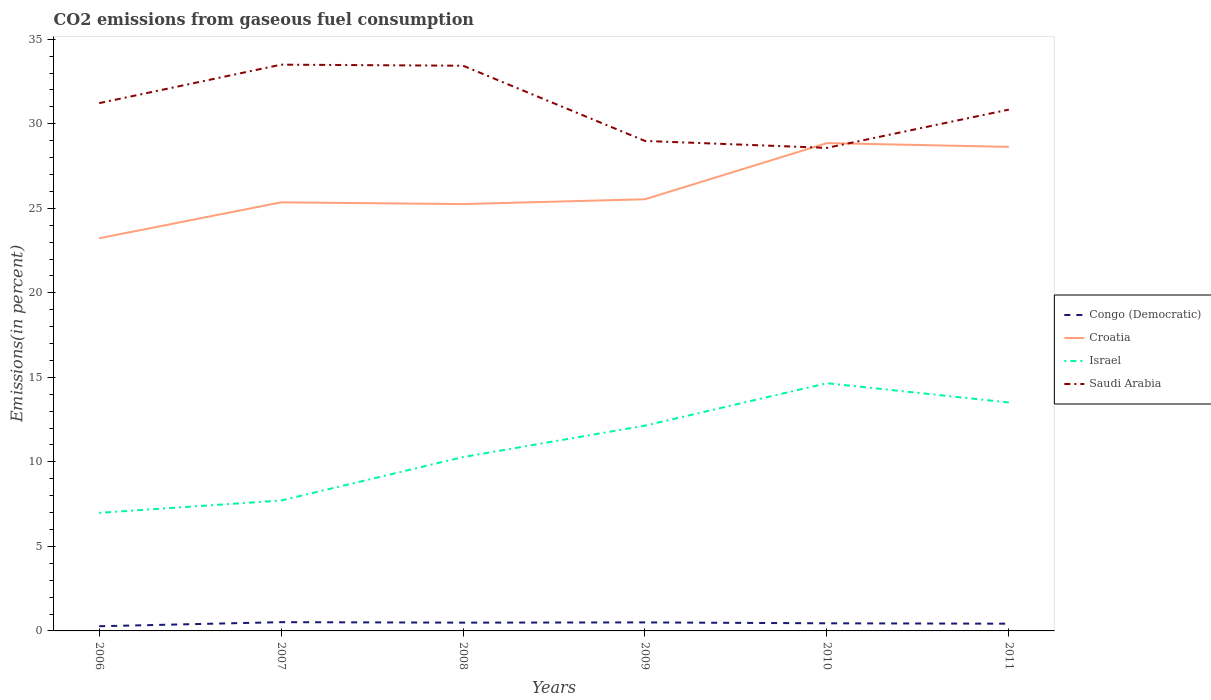How many different coloured lines are there?
Make the answer very short. 4. Is the number of lines equal to the number of legend labels?
Provide a succinct answer. Yes. Across all years, what is the maximum total CO2 emitted in Congo (Democratic)?
Provide a short and direct response. 0.28. What is the total total CO2 emitted in Israel in the graph?
Offer a very short reply. -7.67. What is the difference between the highest and the second highest total CO2 emitted in Israel?
Offer a terse response. 7.67. What is the difference between the highest and the lowest total CO2 emitted in Croatia?
Make the answer very short. 2. How many years are there in the graph?
Keep it short and to the point. 6. Are the values on the major ticks of Y-axis written in scientific E-notation?
Offer a terse response. No. How many legend labels are there?
Make the answer very short. 4. How are the legend labels stacked?
Give a very brief answer. Vertical. What is the title of the graph?
Your answer should be compact. CO2 emissions from gaseous fuel consumption. Does "Micronesia" appear as one of the legend labels in the graph?
Make the answer very short. No. What is the label or title of the X-axis?
Provide a short and direct response. Years. What is the label or title of the Y-axis?
Keep it short and to the point. Emissions(in percent). What is the Emissions(in percent) of Congo (Democratic) in 2006?
Provide a short and direct response. 0.28. What is the Emissions(in percent) in Croatia in 2006?
Your response must be concise. 23.23. What is the Emissions(in percent) of Israel in 2006?
Your response must be concise. 6.98. What is the Emissions(in percent) in Saudi Arabia in 2006?
Provide a short and direct response. 31.22. What is the Emissions(in percent) of Congo (Democratic) in 2007?
Offer a terse response. 0.52. What is the Emissions(in percent) in Croatia in 2007?
Your answer should be compact. 25.35. What is the Emissions(in percent) of Israel in 2007?
Make the answer very short. 7.72. What is the Emissions(in percent) of Saudi Arabia in 2007?
Provide a succinct answer. 33.5. What is the Emissions(in percent) in Congo (Democratic) in 2008?
Provide a succinct answer. 0.49. What is the Emissions(in percent) in Croatia in 2008?
Make the answer very short. 25.25. What is the Emissions(in percent) in Israel in 2008?
Your response must be concise. 10.29. What is the Emissions(in percent) in Saudi Arabia in 2008?
Your answer should be very brief. 33.44. What is the Emissions(in percent) in Congo (Democratic) in 2009?
Offer a terse response. 0.5. What is the Emissions(in percent) in Croatia in 2009?
Provide a short and direct response. 25.54. What is the Emissions(in percent) in Israel in 2009?
Your response must be concise. 12.14. What is the Emissions(in percent) in Saudi Arabia in 2009?
Provide a short and direct response. 28.99. What is the Emissions(in percent) of Congo (Democratic) in 2010?
Ensure brevity in your answer.  0.45. What is the Emissions(in percent) in Croatia in 2010?
Offer a terse response. 28.86. What is the Emissions(in percent) in Israel in 2010?
Provide a succinct answer. 14.65. What is the Emissions(in percent) in Saudi Arabia in 2010?
Make the answer very short. 28.57. What is the Emissions(in percent) in Congo (Democratic) in 2011?
Ensure brevity in your answer.  0.43. What is the Emissions(in percent) in Croatia in 2011?
Make the answer very short. 28.64. What is the Emissions(in percent) in Israel in 2011?
Offer a terse response. 13.51. What is the Emissions(in percent) in Saudi Arabia in 2011?
Offer a very short reply. 30.84. Across all years, what is the maximum Emissions(in percent) of Congo (Democratic)?
Offer a terse response. 0.52. Across all years, what is the maximum Emissions(in percent) in Croatia?
Your answer should be very brief. 28.86. Across all years, what is the maximum Emissions(in percent) of Israel?
Your response must be concise. 14.65. Across all years, what is the maximum Emissions(in percent) in Saudi Arabia?
Your answer should be very brief. 33.5. Across all years, what is the minimum Emissions(in percent) of Congo (Democratic)?
Ensure brevity in your answer.  0.28. Across all years, what is the minimum Emissions(in percent) of Croatia?
Your answer should be compact. 23.23. Across all years, what is the minimum Emissions(in percent) of Israel?
Your answer should be very brief. 6.98. Across all years, what is the minimum Emissions(in percent) of Saudi Arabia?
Your response must be concise. 28.57. What is the total Emissions(in percent) of Congo (Democratic) in the graph?
Your answer should be compact. 2.67. What is the total Emissions(in percent) of Croatia in the graph?
Ensure brevity in your answer.  156.86. What is the total Emissions(in percent) of Israel in the graph?
Provide a short and direct response. 65.3. What is the total Emissions(in percent) of Saudi Arabia in the graph?
Provide a short and direct response. 186.56. What is the difference between the Emissions(in percent) in Congo (Democratic) in 2006 and that in 2007?
Offer a very short reply. -0.24. What is the difference between the Emissions(in percent) in Croatia in 2006 and that in 2007?
Keep it short and to the point. -2.13. What is the difference between the Emissions(in percent) of Israel in 2006 and that in 2007?
Give a very brief answer. -0.73. What is the difference between the Emissions(in percent) in Saudi Arabia in 2006 and that in 2007?
Keep it short and to the point. -2.28. What is the difference between the Emissions(in percent) of Congo (Democratic) in 2006 and that in 2008?
Provide a short and direct response. -0.21. What is the difference between the Emissions(in percent) in Croatia in 2006 and that in 2008?
Your answer should be compact. -2.02. What is the difference between the Emissions(in percent) of Israel in 2006 and that in 2008?
Make the answer very short. -3.3. What is the difference between the Emissions(in percent) in Saudi Arabia in 2006 and that in 2008?
Make the answer very short. -2.21. What is the difference between the Emissions(in percent) in Congo (Democratic) in 2006 and that in 2009?
Keep it short and to the point. -0.23. What is the difference between the Emissions(in percent) of Croatia in 2006 and that in 2009?
Provide a succinct answer. -2.31. What is the difference between the Emissions(in percent) in Israel in 2006 and that in 2009?
Your answer should be very brief. -5.16. What is the difference between the Emissions(in percent) in Saudi Arabia in 2006 and that in 2009?
Ensure brevity in your answer.  2.24. What is the difference between the Emissions(in percent) in Congo (Democratic) in 2006 and that in 2010?
Offer a very short reply. -0.17. What is the difference between the Emissions(in percent) in Croatia in 2006 and that in 2010?
Your answer should be compact. -5.63. What is the difference between the Emissions(in percent) in Israel in 2006 and that in 2010?
Your response must be concise. -7.67. What is the difference between the Emissions(in percent) of Saudi Arabia in 2006 and that in 2010?
Make the answer very short. 2.65. What is the difference between the Emissions(in percent) of Congo (Democratic) in 2006 and that in 2011?
Your answer should be very brief. -0.15. What is the difference between the Emissions(in percent) in Croatia in 2006 and that in 2011?
Make the answer very short. -5.41. What is the difference between the Emissions(in percent) of Israel in 2006 and that in 2011?
Keep it short and to the point. -6.53. What is the difference between the Emissions(in percent) in Saudi Arabia in 2006 and that in 2011?
Make the answer very short. 0.38. What is the difference between the Emissions(in percent) of Congo (Democratic) in 2007 and that in 2008?
Provide a short and direct response. 0.03. What is the difference between the Emissions(in percent) in Croatia in 2007 and that in 2008?
Your answer should be very brief. 0.1. What is the difference between the Emissions(in percent) of Israel in 2007 and that in 2008?
Make the answer very short. -2.57. What is the difference between the Emissions(in percent) in Saudi Arabia in 2007 and that in 2008?
Ensure brevity in your answer.  0.06. What is the difference between the Emissions(in percent) of Congo (Democratic) in 2007 and that in 2009?
Offer a very short reply. 0.01. What is the difference between the Emissions(in percent) of Croatia in 2007 and that in 2009?
Your response must be concise. -0.18. What is the difference between the Emissions(in percent) of Israel in 2007 and that in 2009?
Give a very brief answer. -4.43. What is the difference between the Emissions(in percent) of Saudi Arabia in 2007 and that in 2009?
Offer a terse response. 4.51. What is the difference between the Emissions(in percent) of Congo (Democratic) in 2007 and that in 2010?
Give a very brief answer. 0.07. What is the difference between the Emissions(in percent) in Croatia in 2007 and that in 2010?
Ensure brevity in your answer.  -3.5. What is the difference between the Emissions(in percent) in Israel in 2007 and that in 2010?
Give a very brief answer. -6.94. What is the difference between the Emissions(in percent) in Saudi Arabia in 2007 and that in 2010?
Provide a succinct answer. 4.92. What is the difference between the Emissions(in percent) of Congo (Democratic) in 2007 and that in 2011?
Your answer should be compact. 0.09. What is the difference between the Emissions(in percent) of Croatia in 2007 and that in 2011?
Provide a short and direct response. -3.28. What is the difference between the Emissions(in percent) of Israel in 2007 and that in 2011?
Provide a succinct answer. -5.8. What is the difference between the Emissions(in percent) of Saudi Arabia in 2007 and that in 2011?
Keep it short and to the point. 2.66. What is the difference between the Emissions(in percent) of Congo (Democratic) in 2008 and that in 2009?
Give a very brief answer. -0.01. What is the difference between the Emissions(in percent) in Croatia in 2008 and that in 2009?
Ensure brevity in your answer.  -0.28. What is the difference between the Emissions(in percent) in Israel in 2008 and that in 2009?
Ensure brevity in your answer.  -1.86. What is the difference between the Emissions(in percent) in Saudi Arabia in 2008 and that in 2009?
Provide a short and direct response. 4.45. What is the difference between the Emissions(in percent) in Congo (Democratic) in 2008 and that in 2010?
Offer a terse response. 0.04. What is the difference between the Emissions(in percent) of Croatia in 2008 and that in 2010?
Give a very brief answer. -3.61. What is the difference between the Emissions(in percent) in Israel in 2008 and that in 2010?
Keep it short and to the point. -4.37. What is the difference between the Emissions(in percent) of Saudi Arabia in 2008 and that in 2010?
Provide a succinct answer. 4.86. What is the difference between the Emissions(in percent) in Congo (Democratic) in 2008 and that in 2011?
Give a very brief answer. 0.06. What is the difference between the Emissions(in percent) of Croatia in 2008 and that in 2011?
Offer a very short reply. -3.38. What is the difference between the Emissions(in percent) of Israel in 2008 and that in 2011?
Offer a terse response. -3.23. What is the difference between the Emissions(in percent) of Saudi Arabia in 2008 and that in 2011?
Make the answer very short. 2.6. What is the difference between the Emissions(in percent) in Congo (Democratic) in 2009 and that in 2010?
Ensure brevity in your answer.  0.05. What is the difference between the Emissions(in percent) in Croatia in 2009 and that in 2010?
Provide a short and direct response. -3.32. What is the difference between the Emissions(in percent) of Israel in 2009 and that in 2010?
Offer a terse response. -2.51. What is the difference between the Emissions(in percent) in Saudi Arabia in 2009 and that in 2010?
Your answer should be very brief. 0.41. What is the difference between the Emissions(in percent) in Congo (Democratic) in 2009 and that in 2011?
Your answer should be very brief. 0.08. What is the difference between the Emissions(in percent) in Croatia in 2009 and that in 2011?
Make the answer very short. -3.1. What is the difference between the Emissions(in percent) of Israel in 2009 and that in 2011?
Your answer should be very brief. -1.37. What is the difference between the Emissions(in percent) of Saudi Arabia in 2009 and that in 2011?
Keep it short and to the point. -1.85. What is the difference between the Emissions(in percent) of Congo (Democratic) in 2010 and that in 2011?
Your answer should be very brief. 0.02. What is the difference between the Emissions(in percent) in Croatia in 2010 and that in 2011?
Make the answer very short. 0.22. What is the difference between the Emissions(in percent) of Israel in 2010 and that in 2011?
Provide a succinct answer. 1.14. What is the difference between the Emissions(in percent) of Saudi Arabia in 2010 and that in 2011?
Your response must be concise. -2.27. What is the difference between the Emissions(in percent) of Congo (Democratic) in 2006 and the Emissions(in percent) of Croatia in 2007?
Provide a succinct answer. -25.08. What is the difference between the Emissions(in percent) in Congo (Democratic) in 2006 and the Emissions(in percent) in Israel in 2007?
Your answer should be very brief. -7.44. What is the difference between the Emissions(in percent) in Congo (Democratic) in 2006 and the Emissions(in percent) in Saudi Arabia in 2007?
Ensure brevity in your answer.  -33.22. What is the difference between the Emissions(in percent) of Croatia in 2006 and the Emissions(in percent) of Israel in 2007?
Give a very brief answer. 15.51. What is the difference between the Emissions(in percent) of Croatia in 2006 and the Emissions(in percent) of Saudi Arabia in 2007?
Give a very brief answer. -10.27. What is the difference between the Emissions(in percent) in Israel in 2006 and the Emissions(in percent) in Saudi Arabia in 2007?
Your response must be concise. -26.51. What is the difference between the Emissions(in percent) of Congo (Democratic) in 2006 and the Emissions(in percent) of Croatia in 2008?
Give a very brief answer. -24.97. What is the difference between the Emissions(in percent) of Congo (Democratic) in 2006 and the Emissions(in percent) of Israel in 2008?
Your answer should be compact. -10.01. What is the difference between the Emissions(in percent) in Congo (Democratic) in 2006 and the Emissions(in percent) in Saudi Arabia in 2008?
Make the answer very short. -33.16. What is the difference between the Emissions(in percent) of Croatia in 2006 and the Emissions(in percent) of Israel in 2008?
Offer a terse response. 12.94. What is the difference between the Emissions(in percent) of Croatia in 2006 and the Emissions(in percent) of Saudi Arabia in 2008?
Provide a short and direct response. -10.21. What is the difference between the Emissions(in percent) of Israel in 2006 and the Emissions(in percent) of Saudi Arabia in 2008?
Ensure brevity in your answer.  -26.45. What is the difference between the Emissions(in percent) in Congo (Democratic) in 2006 and the Emissions(in percent) in Croatia in 2009?
Your answer should be very brief. -25.26. What is the difference between the Emissions(in percent) in Congo (Democratic) in 2006 and the Emissions(in percent) in Israel in 2009?
Provide a succinct answer. -11.87. What is the difference between the Emissions(in percent) in Congo (Democratic) in 2006 and the Emissions(in percent) in Saudi Arabia in 2009?
Keep it short and to the point. -28.71. What is the difference between the Emissions(in percent) of Croatia in 2006 and the Emissions(in percent) of Israel in 2009?
Give a very brief answer. 11.08. What is the difference between the Emissions(in percent) of Croatia in 2006 and the Emissions(in percent) of Saudi Arabia in 2009?
Offer a terse response. -5.76. What is the difference between the Emissions(in percent) in Israel in 2006 and the Emissions(in percent) in Saudi Arabia in 2009?
Your answer should be compact. -22. What is the difference between the Emissions(in percent) of Congo (Democratic) in 2006 and the Emissions(in percent) of Croatia in 2010?
Keep it short and to the point. -28.58. What is the difference between the Emissions(in percent) of Congo (Democratic) in 2006 and the Emissions(in percent) of Israel in 2010?
Provide a short and direct response. -14.38. What is the difference between the Emissions(in percent) of Congo (Democratic) in 2006 and the Emissions(in percent) of Saudi Arabia in 2010?
Your response must be concise. -28.3. What is the difference between the Emissions(in percent) of Croatia in 2006 and the Emissions(in percent) of Israel in 2010?
Provide a short and direct response. 8.57. What is the difference between the Emissions(in percent) in Croatia in 2006 and the Emissions(in percent) in Saudi Arabia in 2010?
Offer a very short reply. -5.35. What is the difference between the Emissions(in percent) in Israel in 2006 and the Emissions(in percent) in Saudi Arabia in 2010?
Offer a very short reply. -21.59. What is the difference between the Emissions(in percent) of Congo (Democratic) in 2006 and the Emissions(in percent) of Croatia in 2011?
Give a very brief answer. -28.36. What is the difference between the Emissions(in percent) in Congo (Democratic) in 2006 and the Emissions(in percent) in Israel in 2011?
Make the answer very short. -13.24. What is the difference between the Emissions(in percent) in Congo (Democratic) in 2006 and the Emissions(in percent) in Saudi Arabia in 2011?
Ensure brevity in your answer.  -30.56. What is the difference between the Emissions(in percent) in Croatia in 2006 and the Emissions(in percent) in Israel in 2011?
Your answer should be compact. 9.71. What is the difference between the Emissions(in percent) in Croatia in 2006 and the Emissions(in percent) in Saudi Arabia in 2011?
Make the answer very short. -7.61. What is the difference between the Emissions(in percent) of Israel in 2006 and the Emissions(in percent) of Saudi Arabia in 2011?
Ensure brevity in your answer.  -23.86. What is the difference between the Emissions(in percent) in Congo (Democratic) in 2007 and the Emissions(in percent) in Croatia in 2008?
Your response must be concise. -24.73. What is the difference between the Emissions(in percent) in Congo (Democratic) in 2007 and the Emissions(in percent) in Israel in 2008?
Your response must be concise. -9.77. What is the difference between the Emissions(in percent) of Congo (Democratic) in 2007 and the Emissions(in percent) of Saudi Arabia in 2008?
Provide a succinct answer. -32.92. What is the difference between the Emissions(in percent) in Croatia in 2007 and the Emissions(in percent) in Israel in 2008?
Provide a succinct answer. 15.07. What is the difference between the Emissions(in percent) of Croatia in 2007 and the Emissions(in percent) of Saudi Arabia in 2008?
Keep it short and to the point. -8.08. What is the difference between the Emissions(in percent) of Israel in 2007 and the Emissions(in percent) of Saudi Arabia in 2008?
Make the answer very short. -25.72. What is the difference between the Emissions(in percent) of Congo (Democratic) in 2007 and the Emissions(in percent) of Croatia in 2009?
Your answer should be compact. -25.02. What is the difference between the Emissions(in percent) of Congo (Democratic) in 2007 and the Emissions(in percent) of Israel in 2009?
Your answer should be very brief. -11.62. What is the difference between the Emissions(in percent) of Congo (Democratic) in 2007 and the Emissions(in percent) of Saudi Arabia in 2009?
Make the answer very short. -28.47. What is the difference between the Emissions(in percent) in Croatia in 2007 and the Emissions(in percent) in Israel in 2009?
Keep it short and to the point. 13.21. What is the difference between the Emissions(in percent) in Croatia in 2007 and the Emissions(in percent) in Saudi Arabia in 2009?
Ensure brevity in your answer.  -3.63. What is the difference between the Emissions(in percent) in Israel in 2007 and the Emissions(in percent) in Saudi Arabia in 2009?
Give a very brief answer. -21.27. What is the difference between the Emissions(in percent) in Congo (Democratic) in 2007 and the Emissions(in percent) in Croatia in 2010?
Your answer should be very brief. -28.34. What is the difference between the Emissions(in percent) of Congo (Democratic) in 2007 and the Emissions(in percent) of Israel in 2010?
Offer a very short reply. -14.14. What is the difference between the Emissions(in percent) in Congo (Democratic) in 2007 and the Emissions(in percent) in Saudi Arabia in 2010?
Ensure brevity in your answer.  -28.06. What is the difference between the Emissions(in percent) of Croatia in 2007 and the Emissions(in percent) of Israel in 2010?
Provide a succinct answer. 10.7. What is the difference between the Emissions(in percent) in Croatia in 2007 and the Emissions(in percent) in Saudi Arabia in 2010?
Provide a short and direct response. -3.22. What is the difference between the Emissions(in percent) of Israel in 2007 and the Emissions(in percent) of Saudi Arabia in 2010?
Make the answer very short. -20.86. What is the difference between the Emissions(in percent) of Congo (Democratic) in 2007 and the Emissions(in percent) of Croatia in 2011?
Your answer should be compact. -28.12. What is the difference between the Emissions(in percent) of Congo (Democratic) in 2007 and the Emissions(in percent) of Israel in 2011?
Offer a terse response. -13. What is the difference between the Emissions(in percent) of Congo (Democratic) in 2007 and the Emissions(in percent) of Saudi Arabia in 2011?
Your response must be concise. -30.32. What is the difference between the Emissions(in percent) of Croatia in 2007 and the Emissions(in percent) of Israel in 2011?
Offer a very short reply. 11.84. What is the difference between the Emissions(in percent) in Croatia in 2007 and the Emissions(in percent) in Saudi Arabia in 2011?
Ensure brevity in your answer.  -5.49. What is the difference between the Emissions(in percent) in Israel in 2007 and the Emissions(in percent) in Saudi Arabia in 2011?
Your answer should be very brief. -23.12. What is the difference between the Emissions(in percent) in Congo (Democratic) in 2008 and the Emissions(in percent) in Croatia in 2009?
Your answer should be compact. -25.05. What is the difference between the Emissions(in percent) in Congo (Democratic) in 2008 and the Emissions(in percent) in Israel in 2009?
Provide a succinct answer. -11.65. What is the difference between the Emissions(in percent) in Congo (Democratic) in 2008 and the Emissions(in percent) in Saudi Arabia in 2009?
Your answer should be compact. -28.5. What is the difference between the Emissions(in percent) in Croatia in 2008 and the Emissions(in percent) in Israel in 2009?
Your answer should be compact. 13.11. What is the difference between the Emissions(in percent) in Croatia in 2008 and the Emissions(in percent) in Saudi Arabia in 2009?
Offer a very short reply. -3.73. What is the difference between the Emissions(in percent) of Israel in 2008 and the Emissions(in percent) of Saudi Arabia in 2009?
Provide a succinct answer. -18.7. What is the difference between the Emissions(in percent) of Congo (Democratic) in 2008 and the Emissions(in percent) of Croatia in 2010?
Provide a short and direct response. -28.37. What is the difference between the Emissions(in percent) in Congo (Democratic) in 2008 and the Emissions(in percent) in Israel in 2010?
Your answer should be very brief. -14.16. What is the difference between the Emissions(in percent) of Congo (Democratic) in 2008 and the Emissions(in percent) of Saudi Arabia in 2010?
Your answer should be compact. -28.08. What is the difference between the Emissions(in percent) in Croatia in 2008 and the Emissions(in percent) in Israel in 2010?
Make the answer very short. 10.6. What is the difference between the Emissions(in percent) in Croatia in 2008 and the Emissions(in percent) in Saudi Arabia in 2010?
Your answer should be very brief. -3.32. What is the difference between the Emissions(in percent) in Israel in 2008 and the Emissions(in percent) in Saudi Arabia in 2010?
Your answer should be very brief. -18.29. What is the difference between the Emissions(in percent) of Congo (Democratic) in 2008 and the Emissions(in percent) of Croatia in 2011?
Your answer should be compact. -28.14. What is the difference between the Emissions(in percent) of Congo (Democratic) in 2008 and the Emissions(in percent) of Israel in 2011?
Offer a terse response. -13.02. What is the difference between the Emissions(in percent) in Congo (Democratic) in 2008 and the Emissions(in percent) in Saudi Arabia in 2011?
Keep it short and to the point. -30.35. What is the difference between the Emissions(in percent) in Croatia in 2008 and the Emissions(in percent) in Israel in 2011?
Offer a terse response. 11.74. What is the difference between the Emissions(in percent) of Croatia in 2008 and the Emissions(in percent) of Saudi Arabia in 2011?
Your response must be concise. -5.59. What is the difference between the Emissions(in percent) of Israel in 2008 and the Emissions(in percent) of Saudi Arabia in 2011?
Your answer should be compact. -20.55. What is the difference between the Emissions(in percent) in Congo (Democratic) in 2009 and the Emissions(in percent) in Croatia in 2010?
Provide a short and direct response. -28.35. What is the difference between the Emissions(in percent) of Congo (Democratic) in 2009 and the Emissions(in percent) of Israel in 2010?
Your answer should be compact. -14.15. What is the difference between the Emissions(in percent) in Congo (Democratic) in 2009 and the Emissions(in percent) in Saudi Arabia in 2010?
Provide a succinct answer. -28.07. What is the difference between the Emissions(in percent) in Croatia in 2009 and the Emissions(in percent) in Israel in 2010?
Provide a short and direct response. 10.88. What is the difference between the Emissions(in percent) in Croatia in 2009 and the Emissions(in percent) in Saudi Arabia in 2010?
Make the answer very short. -3.04. What is the difference between the Emissions(in percent) in Israel in 2009 and the Emissions(in percent) in Saudi Arabia in 2010?
Make the answer very short. -16.43. What is the difference between the Emissions(in percent) of Congo (Democratic) in 2009 and the Emissions(in percent) of Croatia in 2011?
Offer a very short reply. -28.13. What is the difference between the Emissions(in percent) of Congo (Democratic) in 2009 and the Emissions(in percent) of Israel in 2011?
Offer a terse response. -13.01. What is the difference between the Emissions(in percent) in Congo (Democratic) in 2009 and the Emissions(in percent) in Saudi Arabia in 2011?
Offer a very short reply. -30.34. What is the difference between the Emissions(in percent) in Croatia in 2009 and the Emissions(in percent) in Israel in 2011?
Offer a very short reply. 12.02. What is the difference between the Emissions(in percent) in Croatia in 2009 and the Emissions(in percent) in Saudi Arabia in 2011?
Give a very brief answer. -5.3. What is the difference between the Emissions(in percent) in Israel in 2009 and the Emissions(in percent) in Saudi Arabia in 2011?
Make the answer very short. -18.7. What is the difference between the Emissions(in percent) in Congo (Democratic) in 2010 and the Emissions(in percent) in Croatia in 2011?
Give a very brief answer. -28.18. What is the difference between the Emissions(in percent) in Congo (Democratic) in 2010 and the Emissions(in percent) in Israel in 2011?
Your answer should be compact. -13.06. What is the difference between the Emissions(in percent) in Congo (Democratic) in 2010 and the Emissions(in percent) in Saudi Arabia in 2011?
Your answer should be very brief. -30.39. What is the difference between the Emissions(in percent) in Croatia in 2010 and the Emissions(in percent) in Israel in 2011?
Make the answer very short. 15.34. What is the difference between the Emissions(in percent) in Croatia in 2010 and the Emissions(in percent) in Saudi Arabia in 2011?
Offer a terse response. -1.98. What is the difference between the Emissions(in percent) in Israel in 2010 and the Emissions(in percent) in Saudi Arabia in 2011?
Keep it short and to the point. -16.19. What is the average Emissions(in percent) in Congo (Democratic) per year?
Make the answer very short. 0.44. What is the average Emissions(in percent) in Croatia per year?
Offer a terse response. 26.14. What is the average Emissions(in percent) in Israel per year?
Make the answer very short. 10.88. What is the average Emissions(in percent) of Saudi Arabia per year?
Make the answer very short. 31.09. In the year 2006, what is the difference between the Emissions(in percent) of Congo (Democratic) and Emissions(in percent) of Croatia?
Provide a succinct answer. -22.95. In the year 2006, what is the difference between the Emissions(in percent) of Congo (Democratic) and Emissions(in percent) of Israel?
Your answer should be compact. -6.71. In the year 2006, what is the difference between the Emissions(in percent) in Congo (Democratic) and Emissions(in percent) in Saudi Arabia?
Make the answer very short. -30.94. In the year 2006, what is the difference between the Emissions(in percent) in Croatia and Emissions(in percent) in Israel?
Offer a very short reply. 16.24. In the year 2006, what is the difference between the Emissions(in percent) of Croatia and Emissions(in percent) of Saudi Arabia?
Ensure brevity in your answer.  -7.99. In the year 2006, what is the difference between the Emissions(in percent) of Israel and Emissions(in percent) of Saudi Arabia?
Your answer should be compact. -24.24. In the year 2007, what is the difference between the Emissions(in percent) in Congo (Democratic) and Emissions(in percent) in Croatia?
Provide a short and direct response. -24.84. In the year 2007, what is the difference between the Emissions(in percent) of Congo (Democratic) and Emissions(in percent) of Israel?
Keep it short and to the point. -7.2. In the year 2007, what is the difference between the Emissions(in percent) in Congo (Democratic) and Emissions(in percent) in Saudi Arabia?
Make the answer very short. -32.98. In the year 2007, what is the difference between the Emissions(in percent) of Croatia and Emissions(in percent) of Israel?
Ensure brevity in your answer.  17.64. In the year 2007, what is the difference between the Emissions(in percent) in Croatia and Emissions(in percent) in Saudi Arabia?
Make the answer very short. -8.15. In the year 2007, what is the difference between the Emissions(in percent) of Israel and Emissions(in percent) of Saudi Arabia?
Your answer should be compact. -25.78. In the year 2008, what is the difference between the Emissions(in percent) of Congo (Democratic) and Emissions(in percent) of Croatia?
Give a very brief answer. -24.76. In the year 2008, what is the difference between the Emissions(in percent) of Congo (Democratic) and Emissions(in percent) of Israel?
Ensure brevity in your answer.  -9.8. In the year 2008, what is the difference between the Emissions(in percent) of Congo (Democratic) and Emissions(in percent) of Saudi Arabia?
Ensure brevity in your answer.  -32.95. In the year 2008, what is the difference between the Emissions(in percent) in Croatia and Emissions(in percent) in Israel?
Your answer should be compact. 14.96. In the year 2008, what is the difference between the Emissions(in percent) of Croatia and Emissions(in percent) of Saudi Arabia?
Make the answer very short. -8.18. In the year 2008, what is the difference between the Emissions(in percent) in Israel and Emissions(in percent) in Saudi Arabia?
Your answer should be very brief. -23.15. In the year 2009, what is the difference between the Emissions(in percent) of Congo (Democratic) and Emissions(in percent) of Croatia?
Offer a terse response. -25.03. In the year 2009, what is the difference between the Emissions(in percent) in Congo (Democratic) and Emissions(in percent) in Israel?
Provide a short and direct response. -11.64. In the year 2009, what is the difference between the Emissions(in percent) of Congo (Democratic) and Emissions(in percent) of Saudi Arabia?
Offer a terse response. -28.48. In the year 2009, what is the difference between the Emissions(in percent) in Croatia and Emissions(in percent) in Israel?
Give a very brief answer. 13.39. In the year 2009, what is the difference between the Emissions(in percent) in Croatia and Emissions(in percent) in Saudi Arabia?
Offer a terse response. -3.45. In the year 2009, what is the difference between the Emissions(in percent) in Israel and Emissions(in percent) in Saudi Arabia?
Your response must be concise. -16.84. In the year 2010, what is the difference between the Emissions(in percent) of Congo (Democratic) and Emissions(in percent) of Croatia?
Your answer should be very brief. -28.41. In the year 2010, what is the difference between the Emissions(in percent) of Congo (Democratic) and Emissions(in percent) of Israel?
Your response must be concise. -14.2. In the year 2010, what is the difference between the Emissions(in percent) in Congo (Democratic) and Emissions(in percent) in Saudi Arabia?
Keep it short and to the point. -28.12. In the year 2010, what is the difference between the Emissions(in percent) of Croatia and Emissions(in percent) of Israel?
Provide a succinct answer. 14.2. In the year 2010, what is the difference between the Emissions(in percent) of Croatia and Emissions(in percent) of Saudi Arabia?
Offer a very short reply. 0.28. In the year 2010, what is the difference between the Emissions(in percent) in Israel and Emissions(in percent) in Saudi Arabia?
Provide a succinct answer. -13.92. In the year 2011, what is the difference between the Emissions(in percent) in Congo (Democratic) and Emissions(in percent) in Croatia?
Your answer should be compact. -28.21. In the year 2011, what is the difference between the Emissions(in percent) in Congo (Democratic) and Emissions(in percent) in Israel?
Offer a very short reply. -13.09. In the year 2011, what is the difference between the Emissions(in percent) of Congo (Democratic) and Emissions(in percent) of Saudi Arabia?
Keep it short and to the point. -30.41. In the year 2011, what is the difference between the Emissions(in percent) in Croatia and Emissions(in percent) in Israel?
Keep it short and to the point. 15.12. In the year 2011, what is the difference between the Emissions(in percent) of Croatia and Emissions(in percent) of Saudi Arabia?
Ensure brevity in your answer.  -2.2. In the year 2011, what is the difference between the Emissions(in percent) in Israel and Emissions(in percent) in Saudi Arabia?
Provide a short and direct response. -17.33. What is the ratio of the Emissions(in percent) of Congo (Democratic) in 2006 to that in 2007?
Keep it short and to the point. 0.54. What is the ratio of the Emissions(in percent) of Croatia in 2006 to that in 2007?
Keep it short and to the point. 0.92. What is the ratio of the Emissions(in percent) of Israel in 2006 to that in 2007?
Your answer should be compact. 0.91. What is the ratio of the Emissions(in percent) of Saudi Arabia in 2006 to that in 2007?
Provide a succinct answer. 0.93. What is the ratio of the Emissions(in percent) of Congo (Democratic) in 2006 to that in 2008?
Give a very brief answer. 0.57. What is the ratio of the Emissions(in percent) in Croatia in 2006 to that in 2008?
Keep it short and to the point. 0.92. What is the ratio of the Emissions(in percent) of Israel in 2006 to that in 2008?
Offer a terse response. 0.68. What is the ratio of the Emissions(in percent) of Saudi Arabia in 2006 to that in 2008?
Provide a succinct answer. 0.93. What is the ratio of the Emissions(in percent) in Congo (Democratic) in 2006 to that in 2009?
Give a very brief answer. 0.55. What is the ratio of the Emissions(in percent) in Croatia in 2006 to that in 2009?
Your response must be concise. 0.91. What is the ratio of the Emissions(in percent) of Israel in 2006 to that in 2009?
Your answer should be compact. 0.58. What is the ratio of the Emissions(in percent) in Saudi Arabia in 2006 to that in 2009?
Provide a succinct answer. 1.08. What is the ratio of the Emissions(in percent) in Congo (Democratic) in 2006 to that in 2010?
Make the answer very short. 0.62. What is the ratio of the Emissions(in percent) in Croatia in 2006 to that in 2010?
Your answer should be compact. 0.8. What is the ratio of the Emissions(in percent) of Israel in 2006 to that in 2010?
Make the answer very short. 0.48. What is the ratio of the Emissions(in percent) of Saudi Arabia in 2006 to that in 2010?
Ensure brevity in your answer.  1.09. What is the ratio of the Emissions(in percent) of Congo (Democratic) in 2006 to that in 2011?
Give a very brief answer. 0.65. What is the ratio of the Emissions(in percent) in Croatia in 2006 to that in 2011?
Ensure brevity in your answer.  0.81. What is the ratio of the Emissions(in percent) in Israel in 2006 to that in 2011?
Offer a very short reply. 0.52. What is the ratio of the Emissions(in percent) of Saudi Arabia in 2006 to that in 2011?
Provide a succinct answer. 1.01. What is the ratio of the Emissions(in percent) in Congo (Democratic) in 2007 to that in 2008?
Your answer should be compact. 1.06. What is the ratio of the Emissions(in percent) of Israel in 2007 to that in 2008?
Your answer should be compact. 0.75. What is the ratio of the Emissions(in percent) in Saudi Arabia in 2007 to that in 2008?
Your answer should be compact. 1. What is the ratio of the Emissions(in percent) of Congo (Democratic) in 2007 to that in 2009?
Ensure brevity in your answer.  1.03. What is the ratio of the Emissions(in percent) of Israel in 2007 to that in 2009?
Provide a succinct answer. 0.64. What is the ratio of the Emissions(in percent) in Saudi Arabia in 2007 to that in 2009?
Your answer should be very brief. 1.16. What is the ratio of the Emissions(in percent) in Congo (Democratic) in 2007 to that in 2010?
Offer a terse response. 1.15. What is the ratio of the Emissions(in percent) of Croatia in 2007 to that in 2010?
Ensure brevity in your answer.  0.88. What is the ratio of the Emissions(in percent) in Israel in 2007 to that in 2010?
Your answer should be compact. 0.53. What is the ratio of the Emissions(in percent) of Saudi Arabia in 2007 to that in 2010?
Give a very brief answer. 1.17. What is the ratio of the Emissions(in percent) of Congo (Democratic) in 2007 to that in 2011?
Your response must be concise. 1.21. What is the ratio of the Emissions(in percent) of Croatia in 2007 to that in 2011?
Provide a short and direct response. 0.89. What is the ratio of the Emissions(in percent) of Israel in 2007 to that in 2011?
Provide a short and direct response. 0.57. What is the ratio of the Emissions(in percent) in Saudi Arabia in 2007 to that in 2011?
Make the answer very short. 1.09. What is the ratio of the Emissions(in percent) in Congo (Democratic) in 2008 to that in 2009?
Make the answer very short. 0.97. What is the ratio of the Emissions(in percent) of Israel in 2008 to that in 2009?
Your response must be concise. 0.85. What is the ratio of the Emissions(in percent) of Saudi Arabia in 2008 to that in 2009?
Provide a short and direct response. 1.15. What is the ratio of the Emissions(in percent) of Congo (Democratic) in 2008 to that in 2010?
Make the answer very short. 1.09. What is the ratio of the Emissions(in percent) of Israel in 2008 to that in 2010?
Your answer should be very brief. 0.7. What is the ratio of the Emissions(in percent) of Saudi Arabia in 2008 to that in 2010?
Make the answer very short. 1.17. What is the ratio of the Emissions(in percent) in Congo (Democratic) in 2008 to that in 2011?
Provide a short and direct response. 1.14. What is the ratio of the Emissions(in percent) in Croatia in 2008 to that in 2011?
Your answer should be compact. 0.88. What is the ratio of the Emissions(in percent) in Israel in 2008 to that in 2011?
Give a very brief answer. 0.76. What is the ratio of the Emissions(in percent) in Saudi Arabia in 2008 to that in 2011?
Provide a short and direct response. 1.08. What is the ratio of the Emissions(in percent) in Congo (Democratic) in 2009 to that in 2010?
Provide a short and direct response. 1.12. What is the ratio of the Emissions(in percent) in Croatia in 2009 to that in 2010?
Offer a terse response. 0.88. What is the ratio of the Emissions(in percent) of Israel in 2009 to that in 2010?
Provide a succinct answer. 0.83. What is the ratio of the Emissions(in percent) in Saudi Arabia in 2009 to that in 2010?
Provide a succinct answer. 1.01. What is the ratio of the Emissions(in percent) in Congo (Democratic) in 2009 to that in 2011?
Provide a short and direct response. 1.18. What is the ratio of the Emissions(in percent) of Croatia in 2009 to that in 2011?
Give a very brief answer. 0.89. What is the ratio of the Emissions(in percent) of Israel in 2009 to that in 2011?
Provide a short and direct response. 0.9. What is the ratio of the Emissions(in percent) in Saudi Arabia in 2009 to that in 2011?
Provide a succinct answer. 0.94. What is the ratio of the Emissions(in percent) in Congo (Democratic) in 2010 to that in 2011?
Make the answer very short. 1.05. What is the ratio of the Emissions(in percent) in Israel in 2010 to that in 2011?
Your answer should be very brief. 1.08. What is the ratio of the Emissions(in percent) of Saudi Arabia in 2010 to that in 2011?
Offer a very short reply. 0.93. What is the difference between the highest and the second highest Emissions(in percent) in Congo (Democratic)?
Offer a terse response. 0.01. What is the difference between the highest and the second highest Emissions(in percent) in Croatia?
Your answer should be compact. 0.22. What is the difference between the highest and the second highest Emissions(in percent) in Israel?
Your answer should be compact. 1.14. What is the difference between the highest and the second highest Emissions(in percent) of Saudi Arabia?
Keep it short and to the point. 0.06. What is the difference between the highest and the lowest Emissions(in percent) of Congo (Democratic)?
Keep it short and to the point. 0.24. What is the difference between the highest and the lowest Emissions(in percent) of Croatia?
Ensure brevity in your answer.  5.63. What is the difference between the highest and the lowest Emissions(in percent) in Israel?
Your response must be concise. 7.67. What is the difference between the highest and the lowest Emissions(in percent) in Saudi Arabia?
Offer a very short reply. 4.92. 